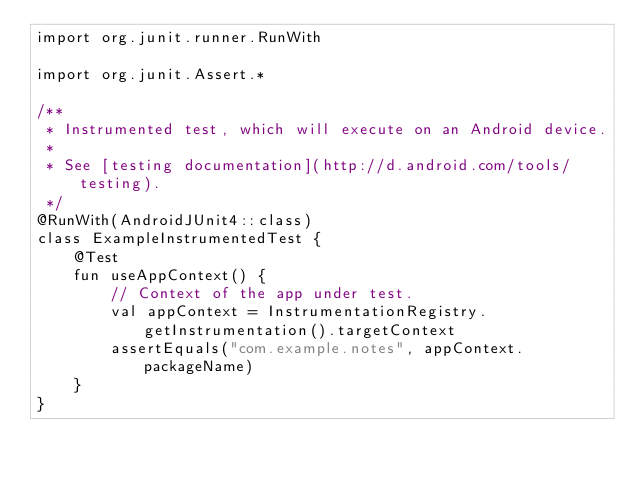<code> <loc_0><loc_0><loc_500><loc_500><_Kotlin_>import org.junit.runner.RunWith

import org.junit.Assert.*

/**
 * Instrumented test, which will execute on an Android device.
 *
 * See [testing documentation](http://d.android.com/tools/testing).
 */
@RunWith(AndroidJUnit4::class)
class ExampleInstrumentedTest {
    @Test
    fun useAppContext() {
        // Context of the app under test.
        val appContext = InstrumentationRegistry.getInstrumentation().targetContext
        assertEquals("com.example.notes", appContext.packageName)
    }
}
</code> 